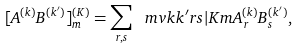<formula> <loc_0><loc_0><loc_500><loc_500>[ A ^ { ( k ) } B ^ { ( k ^ { \prime } ) } ] ^ { ( K ) } _ { m } = \sum _ { r , s } \ m v { k k ^ { \prime } r s | K m } A ^ { ( k ) } _ { r } B ^ { ( k ^ { \prime } ) } _ { s } ,</formula> 